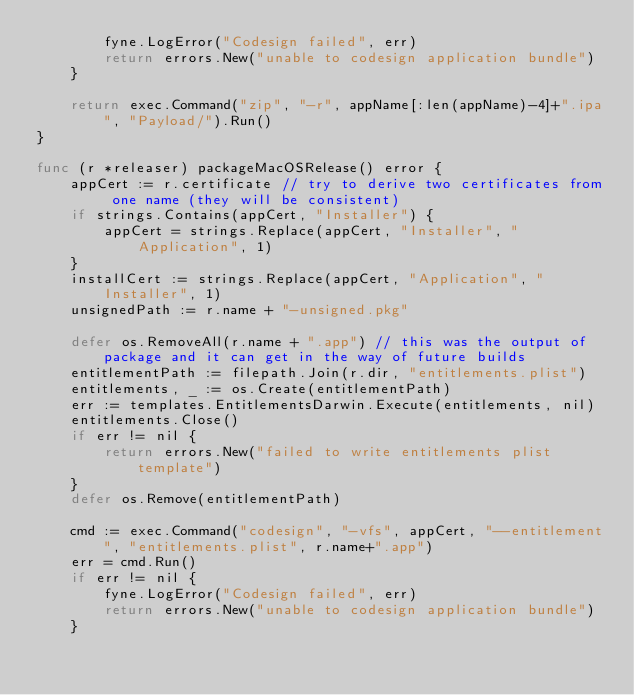<code> <loc_0><loc_0><loc_500><loc_500><_Go_>		fyne.LogError("Codesign failed", err)
		return errors.New("unable to codesign application bundle")
	}

	return exec.Command("zip", "-r", appName[:len(appName)-4]+".ipa", "Payload/").Run()
}

func (r *releaser) packageMacOSRelease() error {
	appCert := r.certificate // try to derive two certificates from one name (they will be consistent)
	if strings.Contains(appCert, "Installer") {
		appCert = strings.Replace(appCert, "Installer", "Application", 1)
	}
	installCert := strings.Replace(appCert, "Application", "Installer", 1)
	unsignedPath := r.name + "-unsigned.pkg"

	defer os.RemoveAll(r.name + ".app") // this was the output of package and it can get in the way of future builds
	entitlementPath := filepath.Join(r.dir, "entitlements.plist")
	entitlements, _ := os.Create(entitlementPath)
	err := templates.EntitlementsDarwin.Execute(entitlements, nil)
	entitlements.Close()
	if err != nil {
		return errors.New("failed to write entitlements plist template")
	}
	defer os.Remove(entitlementPath)

	cmd := exec.Command("codesign", "-vfs", appCert, "--entitlement", "entitlements.plist", r.name+".app")
	err = cmd.Run()
	if err != nil {
		fyne.LogError("Codesign failed", err)
		return errors.New("unable to codesign application bundle")
	}
</code> 